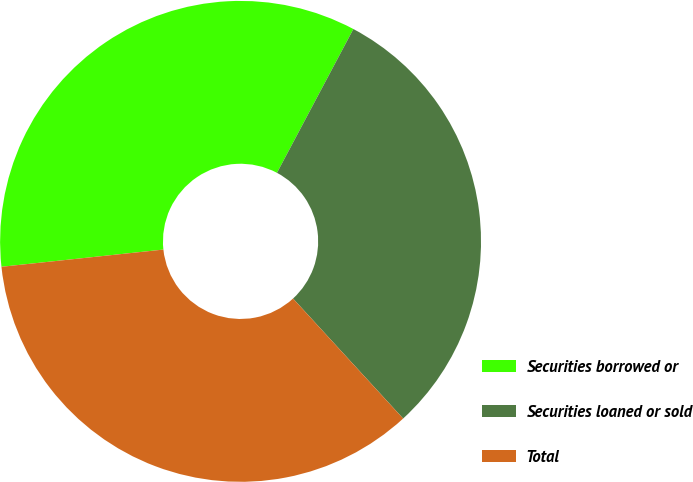Convert chart. <chart><loc_0><loc_0><loc_500><loc_500><pie_chart><fcel>Securities borrowed or<fcel>Securities loaned or sold<fcel>Total<nl><fcel>34.46%<fcel>30.41%<fcel>35.13%<nl></chart> 